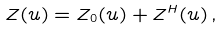Convert formula to latex. <formula><loc_0><loc_0><loc_500><loc_500>Z ( u ) = Z _ { 0 } ( u ) + Z ^ { H } ( u ) \, ,</formula> 